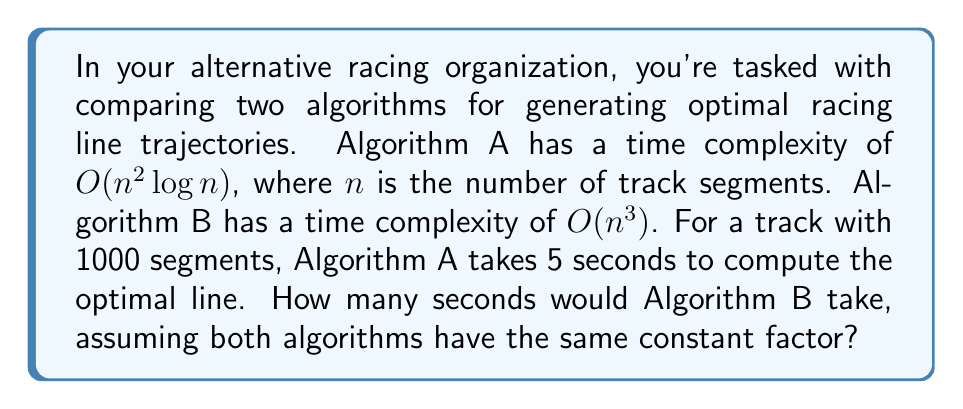Could you help me with this problem? Let's approach this step-by-step:

1) First, we need to understand what the time complexity means. $O(n^2 \log n)$ and $O(n^3)$ describe how the running time grows as $n$ increases.

2) We're told that for $n = 1000$, Algorithm A takes 5 seconds. Let's call the constant factor $k$. So for Algorithm A:

   $k \cdot 1000^2 \log 1000 = 5$ seconds

3) Now, $\log 1000 \approx 10$ (assuming base 2), so:

   $k \cdot 1000^2 \cdot 10 = 5$
   $k \cdot 10^7 = 5$
   $k = 5 \cdot 10^{-7}$

4) For Algorithm B, with the same constant factor:

   Time for B = $k \cdot 1000^3$
               = $5 \cdot 10^{-7} \cdot 1000^3$
               = $5 \cdot 10^{-7} \cdot 10^9$
               = $5 \cdot 10^2$
               = 500 seconds

Therefore, Algorithm B would take 500 seconds to compute the optimal racing line for the same track.
Answer: 500 seconds 